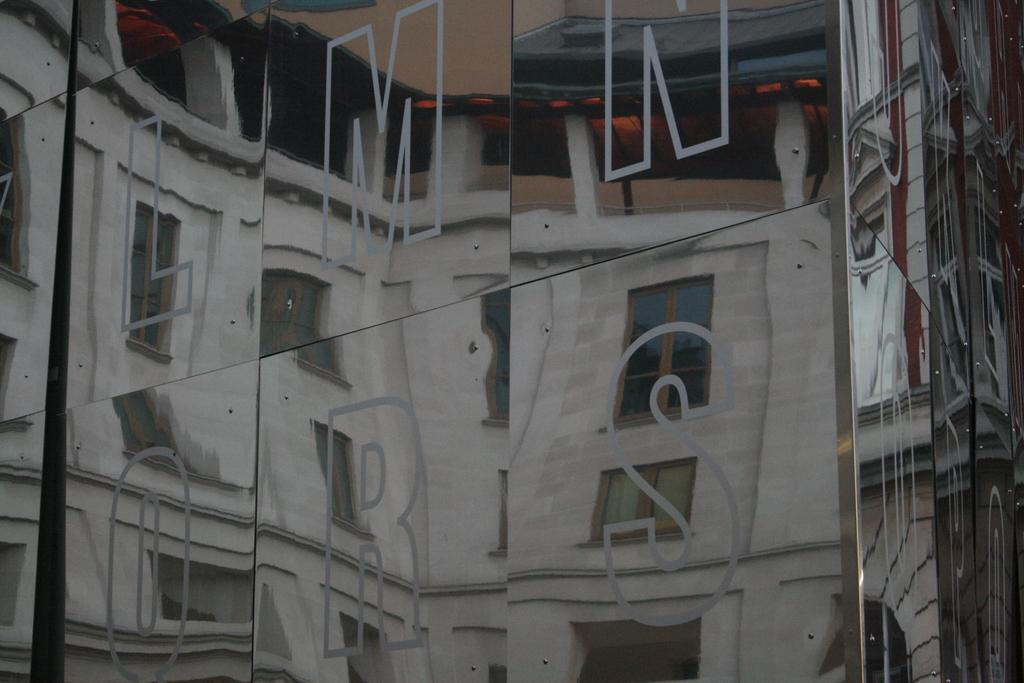In one or two sentences, can you explain what this image depicts? In this image we can see the letters on the glass wall and through the glass wall we can see the building with the windows. 